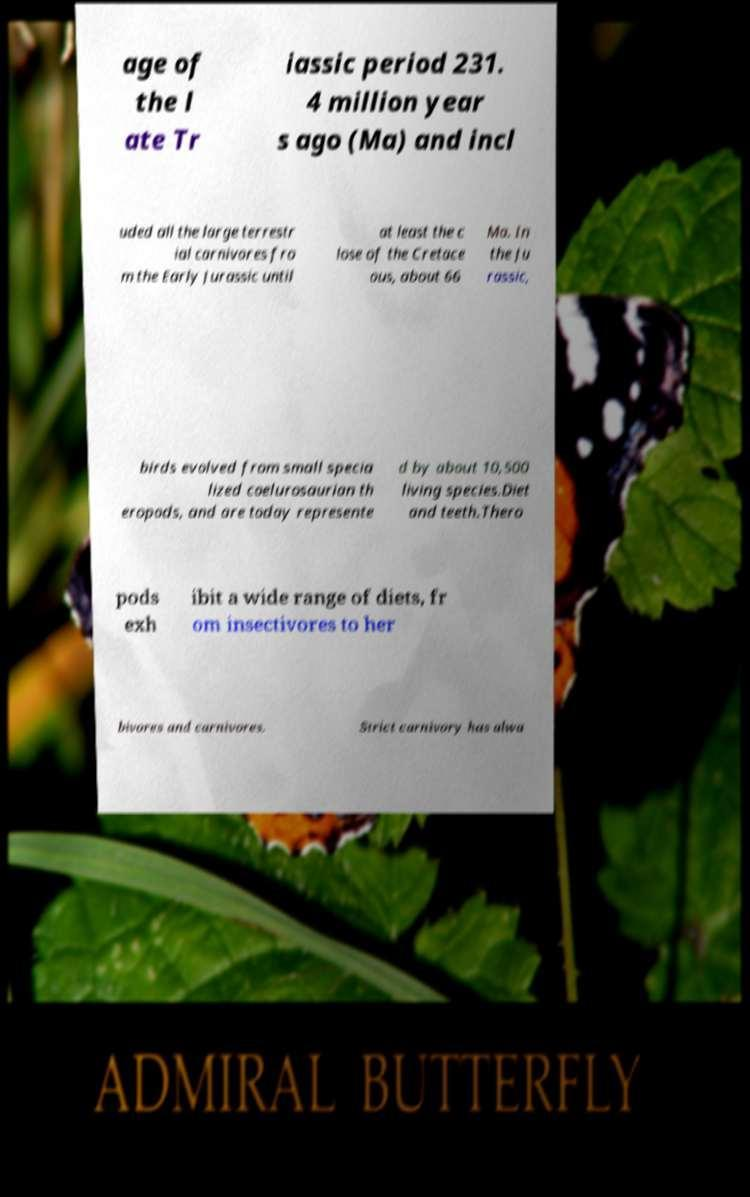Could you extract and type out the text from this image? age of the l ate Tr iassic period 231. 4 million year s ago (Ma) and incl uded all the large terrestr ial carnivores fro m the Early Jurassic until at least the c lose of the Cretace ous, about 66 Ma. In the Ju rassic, birds evolved from small specia lized coelurosaurian th eropods, and are today represente d by about 10,500 living species.Diet and teeth.Thero pods exh ibit a wide range of diets, fr om insectivores to her bivores and carnivores. Strict carnivory has alwa 